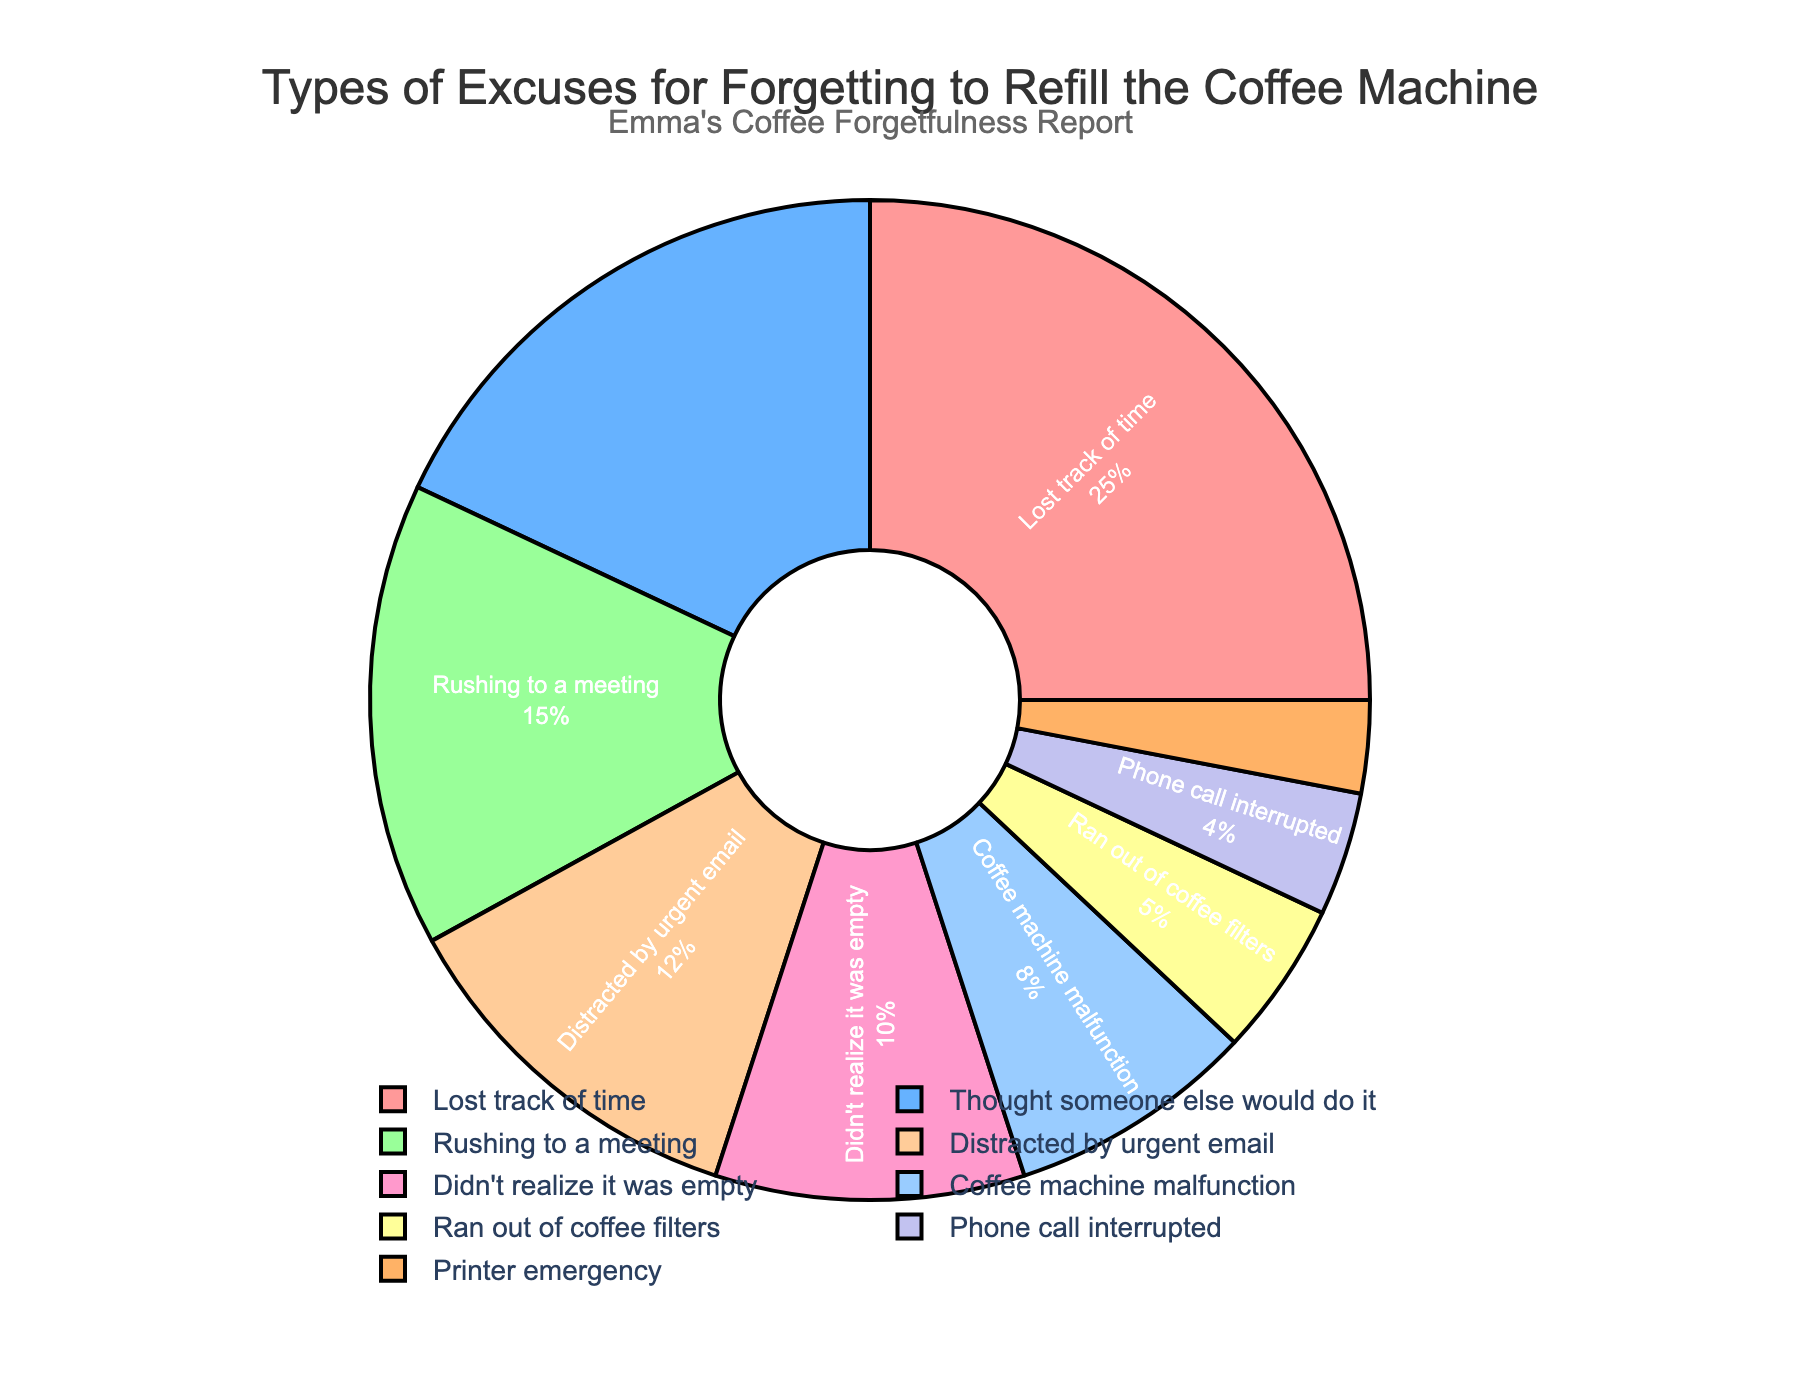What excuse was used the least for forgetting to refill the coffee machine? By examining the pie chart, we look for the smallest segment to find the least used excuse, which is the "Printer emergency" at 3%.
Answer: Printer emergency Which excuse was used the most for forgetting to refill the coffee machine? By examining the pie chart, we look for the largest segment to find the most used excuse, which is "Lost track of time" at 25%.
Answer: Lost track of time What's the combined percentage of people who used "Rushing to a meeting" and "Distracted by urgent email" as excuses? Add the percentages of these two excuses: 15% (Rushing to a meeting) + 12% (Distracted by urgent email) = 27%.
Answer: 27% Which excuses have a percentage lower than 10%? Identify and list all excuses with percentages below 10%: Coffee machine malfunction, Ran out of coffee filters, Phone call interrupted, and Printer emergency.
Answer: Coffee machine malfunction, Ran out of coffee filters, Phone call interrupted, Printer emergency How much larger is the percentage for "Lost track of time" compared to "Didn't realize it was empty"? Subtract the percentage for "Didn't realize it was empty" from "Lost track of time": 25% - 10% = 15%.
Answer: 15% Compare the percentages of the excuses "Thought someone else would do it" and "Distracted by urgent email". Which one is higher? From the pie chart, "Thought someone else would do it" is 18%, and "Distracted by urgent email" is 12%. Therefore, "Thought someone else would do it" is higher.
Answer: Thought someone else would do it What is the percentage difference between "Rushing to a meeting" and "Ran out of coffee filters"? Subtract the percentage for "Ran out of coffee filters" from "Rushing to a meeting": 15% - 5% = 10%.
Answer: 10% What is the total percentage of excuses mentioned that are due to unexpected interruptions ("Phone call interrupted" and "Printer emergency")? Add the percentages of these two excuses: 4% (Phone call interrupted) + 3% (Printer emergency) = 7%.
Answer: 7% How does the percentage of "Thought someone else would do it" compare to the combined percentage of "Phone call interrupted" and "Printer emergency"? The combined percentage of "Phone call interrupted" and "Printer emergency" is 4% + 3% = 7%, and "Thought someone else would do it" is 18%. 18% is greater than 7%.
Answer: Thought someone else would do it > combined percentage of Phone call interrupted and Printer emergency Which visual attribute is displayed in the color segment associated with the highest percentage? The segment with the highest percentage, "Lost track of time," is displayed in red.
Answer: Red 